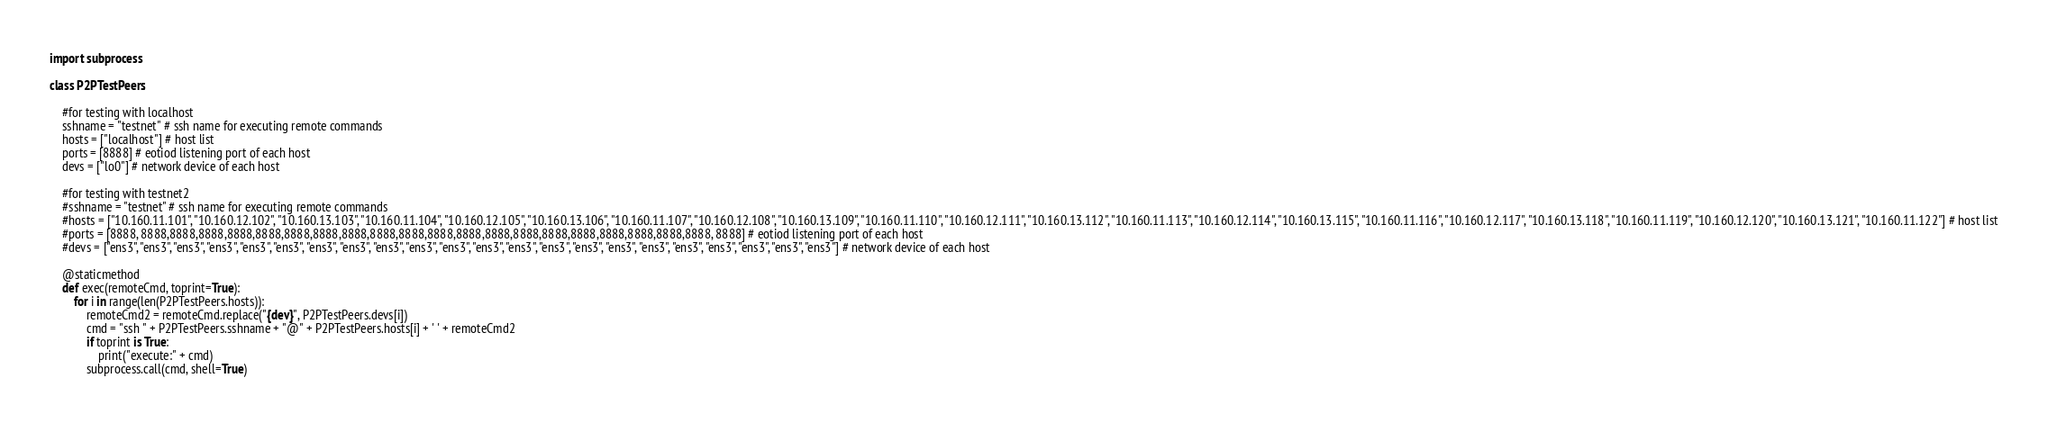<code> <loc_0><loc_0><loc_500><loc_500><_Python_>import subprocess

class P2PTestPeers:

    #for testing with localhost
    sshname = "testnet" # ssh name for executing remote commands
    hosts = ["localhost"] # host list
    ports = [8888] # eotiod listening port of each host
    devs = ["lo0"] # network device of each host

    #for testing with testnet2
    #sshname = "testnet" # ssh name for executing remote commands
    #hosts = ["10.160.11.101", "10.160.12.102", "10.160.13.103", "10.160.11.104", "10.160.12.105", "10.160.13.106", "10.160.11.107", "10.160.12.108", "10.160.13.109", "10.160.11.110", "10.160.12.111", "10.160.13.112", "10.160.11.113", "10.160.12.114", "10.160.13.115", "10.160.11.116", "10.160.12.117", "10.160.13.118", "10.160.11.119", "10.160.12.120", "10.160.13.121", "10.160.11.122"] # host list
    #ports = [8888, 8888,8888,8888,8888,8888,8888,8888,8888,8888,8888,8888,8888,8888,8888,8888,8888,8888,8888,8888,8888, 8888] # eotiod listening port of each host
    #devs = ["ens3", "ens3", "ens3", "ens3", "ens3", "ens3", "ens3", "ens3", "ens3", "ens3", "ens3", "ens3", "ens3", "ens3", "ens3", "ens3", "ens3", "ens3", "ens3", "ens3", "ens3", "ens3"] # network device of each host

    @staticmethod
    def exec(remoteCmd, toprint=True):
        for i in range(len(P2PTestPeers.hosts)):
            remoteCmd2 = remoteCmd.replace("{dev}", P2PTestPeers.devs[i])
            cmd = "ssh " + P2PTestPeers.sshname + "@" + P2PTestPeers.hosts[i] + ' ' + remoteCmd2
            if toprint is True:
                print("execute:" + cmd)
            subprocess.call(cmd, shell=True)</code> 